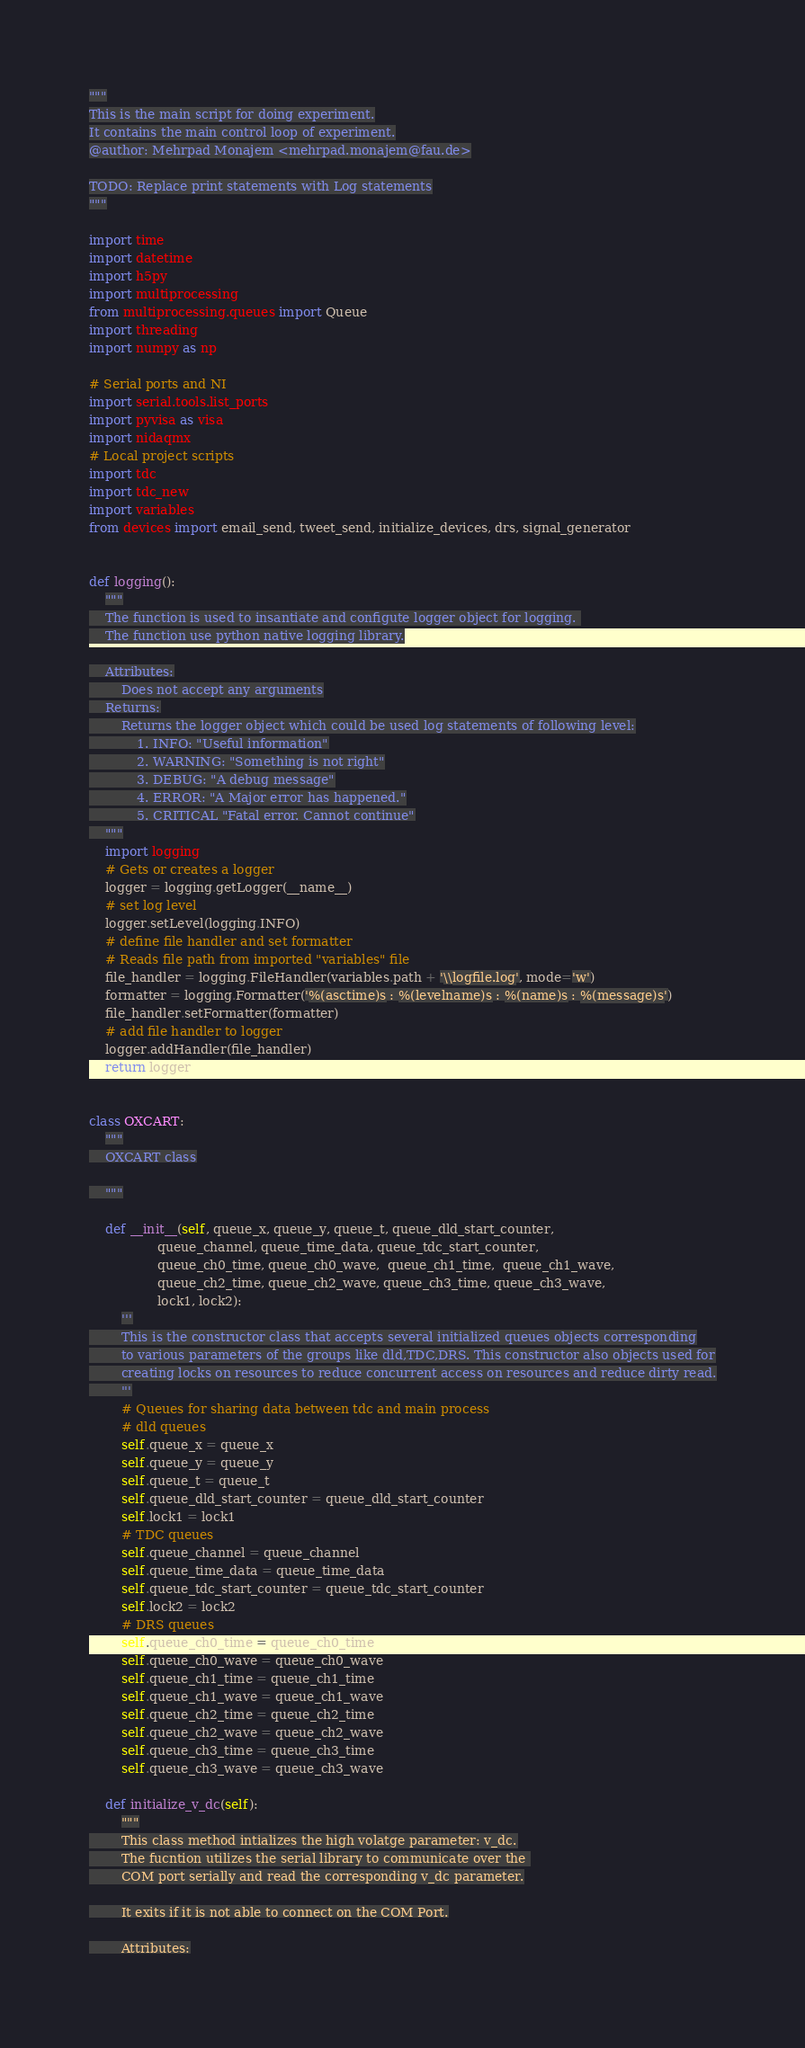Convert code to text. <code><loc_0><loc_0><loc_500><loc_500><_Python_>"""
This is the main script for doing experiment.
It contains the main control loop of experiment.
@author: Mehrpad Monajem <mehrpad.monajem@fau.de>

TODO: Replace print statements with Log statements
"""

import time
import datetime
import h5py
import multiprocessing
from multiprocessing.queues import Queue
import threading
import numpy as np

# Serial ports and NI
import serial.tools.list_ports
import pyvisa as visa
import nidaqmx
# Local project scripts
import tdc
import tdc_new
import variables
from devices import email_send, tweet_send, initialize_devices, drs, signal_generator


def logging():
    """
    The function is used to insantiate and configute logger object for logging. 
    The function use python native logging library.

    Attributes:
        Does not accept any arguments
    Returns:
        Returns the logger object which could be used log statements of following level:
            1. INFO: "Useful information"
            2. WARNING: "Something is not right"
            3. DEBUG: "A debug message"
            4. ERROR: "A Major error has happened."
            5. CRITICAL "Fatal error. Cannot continue"
    """
    import logging
    # Gets or creates a logger
    logger = logging.getLogger(__name__)
    # set log level
    logger.setLevel(logging.INFO)
    # define file handler and set formatter
    # Reads file path from imported "variables" file
    file_handler = logging.FileHandler(variables.path + '\\logfile.log', mode='w')
    formatter = logging.Formatter('%(asctime)s : %(levelname)s : %(name)s : %(message)s')
    file_handler.setFormatter(formatter)
    # add file handler to logger
    logger.addHandler(file_handler)
    return logger


class OXCART:
    """
    OXCART class

    """

    def __init__(self, queue_x, queue_y, queue_t, queue_dld_start_counter,
                 queue_channel, queue_time_data, queue_tdc_start_counter,
                 queue_ch0_time, queue_ch0_wave,  queue_ch1_time,  queue_ch1_wave,
                 queue_ch2_time, queue_ch2_wave, queue_ch3_time, queue_ch3_wave,
                 lock1, lock2):
        '''
        This is the constructor class that accepts several initialized queues objects corresponding
        to various parameters of the groups like dld,TDC,DRS. This constructor also objects used for
        creating locks on resources to reduce concurrent access on resources and reduce dirty read.
        '''
        # Queues for sharing data between tdc and main process
        # dld queues
        self.queue_x = queue_x
        self.queue_y = queue_y
        self.queue_t = queue_t
        self.queue_dld_start_counter = queue_dld_start_counter
        self.lock1 = lock1
        # TDC queues
        self.queue_channel = queue_channel
        self.queue_time_data = queue_time_data
        self.queue_tdc_start_counter = queue_tdc_start_counter
        self.lock2 = lock2
        # DRS queues
        self.queue_ch0_time = queue_ch0_time
        self.queue_ch0_wave = queue_ch0_wave
        self.queue_ch1_time = queue_ch1_time
        self.queue_ch1_wave = queue_ch1_wave
        self.queue_ch2_time = queue_ch2_time
        self.queue_ch2_wave = queue_ch2_wave
        self.queue_ch3_time = queue_ch3_time
        self.queue_ch3_wave = queue_ch3_wave

    def initialize_v_dc(self):
        """
        This class method intializes the high volatge parameter: v_dc.
        The fucntion utilizes the serial library to communicate over the 
        COM port serially and read the corresponding v_dc parameter.

        It exits if it is not able to connect on the COM Port.

        Attributes:</code> 